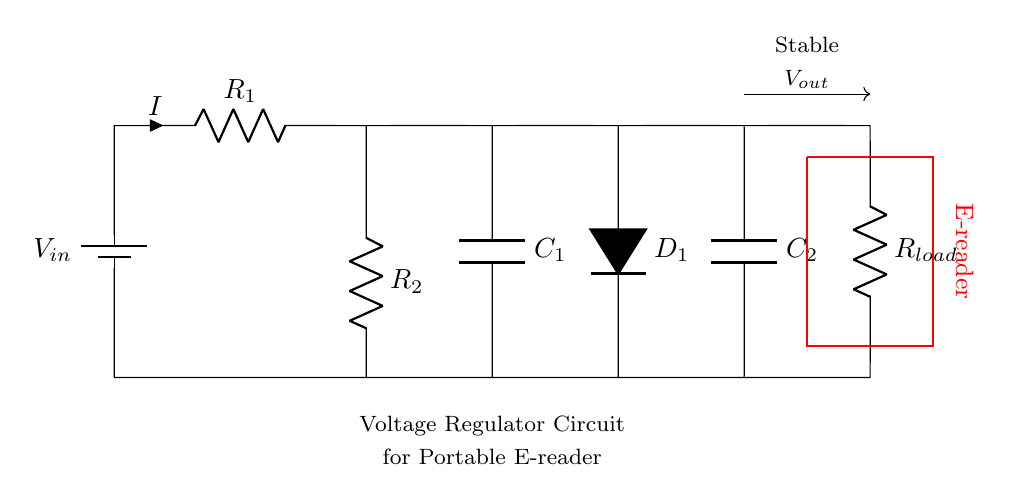What is the input voltage of this circuit? The input voltage is denoted as V in the diagram, typically provided by a battery in the circuit context.
Answer: V in What type of component is D1? D1 is indicated as a diode in the circuit diagram, which allows current to flow in one direction.
Answer: diode What is the role of capacitor C1? Capacitor C1 is connected in parallel to smooth out voltage fluctuations and stabilize the output voltage by storing and releasing charge.
Answer: smoothing What is the configuration type of this circuit? The circuit is designed as a voltage regulator, which ensures a stable output voltage for the load by using resistors, capacitors, and a diode.
Answer: voltage regulator What happens to the load voltage during extended use? During extended reading sessions, the circuit aims to maintain a consistent output voltage despite variations in input or load conditions through energy storage elements.
Answer: consistent What is the value of resistance seen by the load? The resistance seen by the load consists of R2 and the load resistance R load, which can be calculated in series or parallel depending on the total circuit configuration.
Answer: R7 What is the function of C2 in the circuit? Capacitor C2 serves as a filter that helps to further stabilize the voltage output by providing additional energy storage for the load during transient conditions.
Answer: filter 